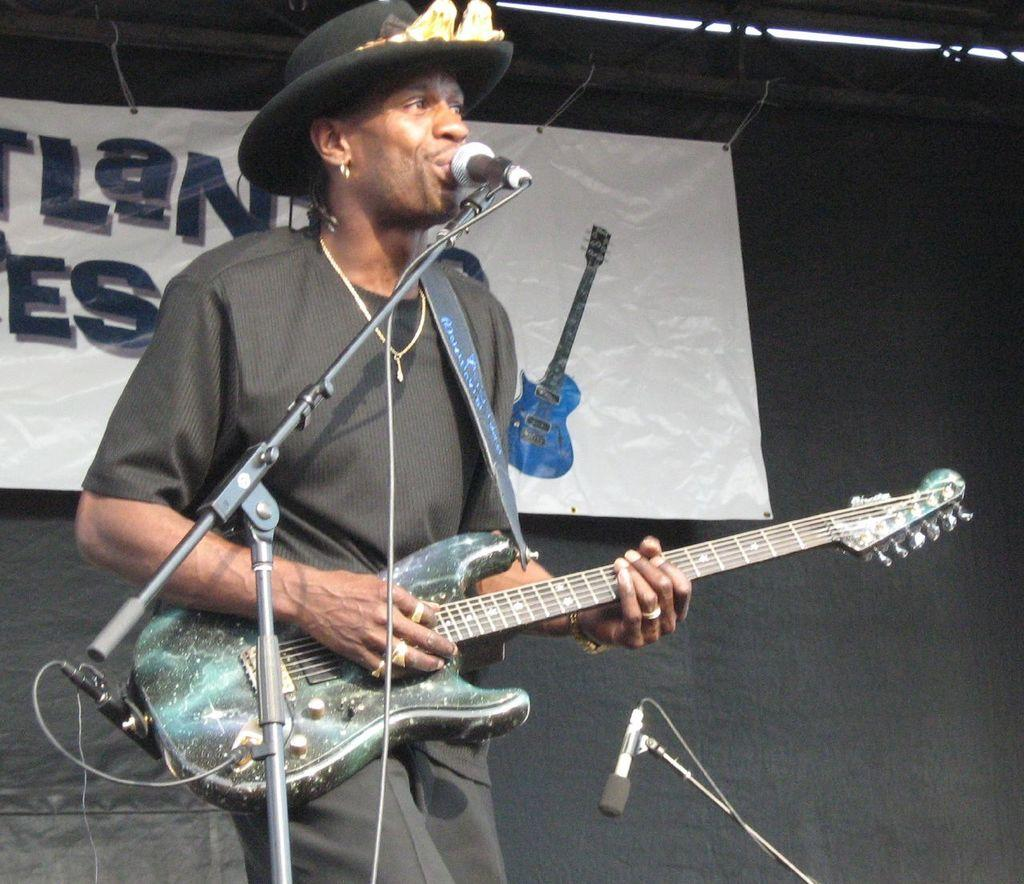What is the man in the image doing? The man is standing and singing in the image. What is the man holding in his hands? The man is holding a guitar in his hands. What is present in the image to amplify the man's voice? There is a microphone and a microphone stand in the image. What can be seen in the background of the image? There is a banner in the image. How does the man maintain a quiet atmosphere while playing the guitar in the image? The image does not depict the man maintaining a quiet atmosphere; he is singing and playing the guitar, which suggests a more audible performance. 